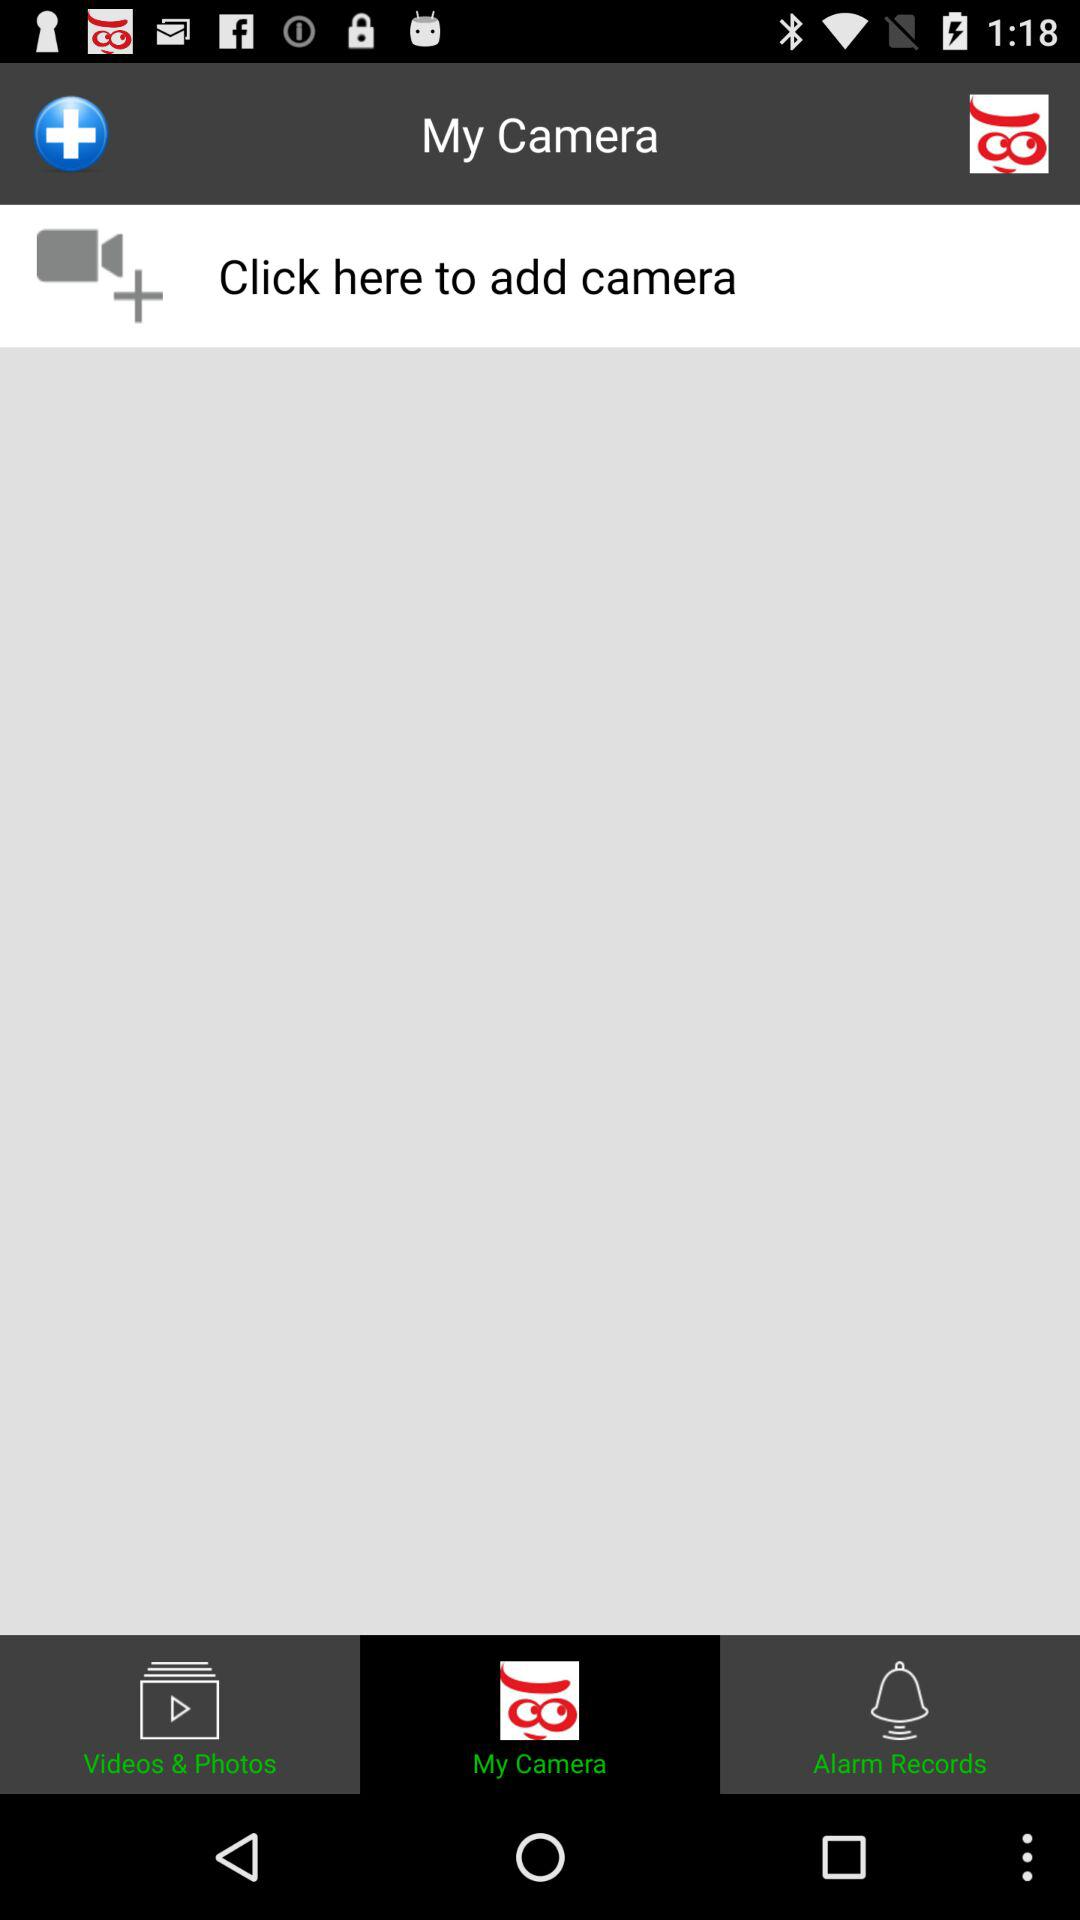Which tab has been selected? The selected tab is "My Camera". 